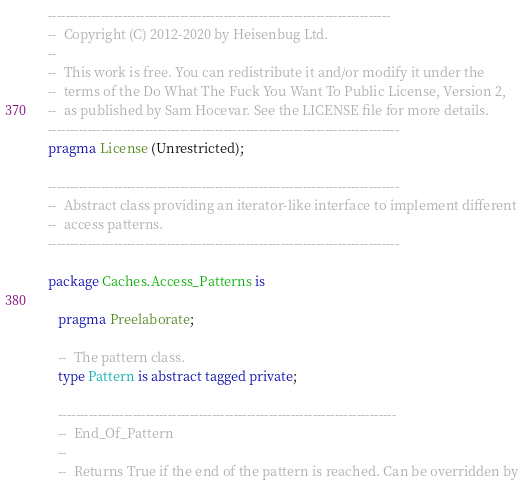Convert code to text. <code><loc_0><loc_0><loc_500><loc_500><_Ada_>------------------------------------------------------------------------------
--  Copyright (C) 2012-2020 by Heisenbug Ltd.
--
--  This work is free. You can redistribute it and/or modify it under the
--  terms of the Do What The Fuck You Want To Public License, Version 2,
--  as published by Sam Hocevar. See the LICENSE file for more details.
--------------------------------------------------------------------------------
pragma License (Unrestricted);

--------------------------------------------------------------------------------
--  Abstract class providing an iterator-like interface to implement different
--  access patterns.
--------------------------------------------------------------------------------

package Caches.Access_Patterns is

   pragma Preelaborate;

   --  The pattern class.
   type Pattern is abstract tagged private;

   -----------------------------------------------------------------------------
   --  End_Of_Pattern
   --
   --  Returns True if the end of the pattern is reached. Can be overridden by</code> 